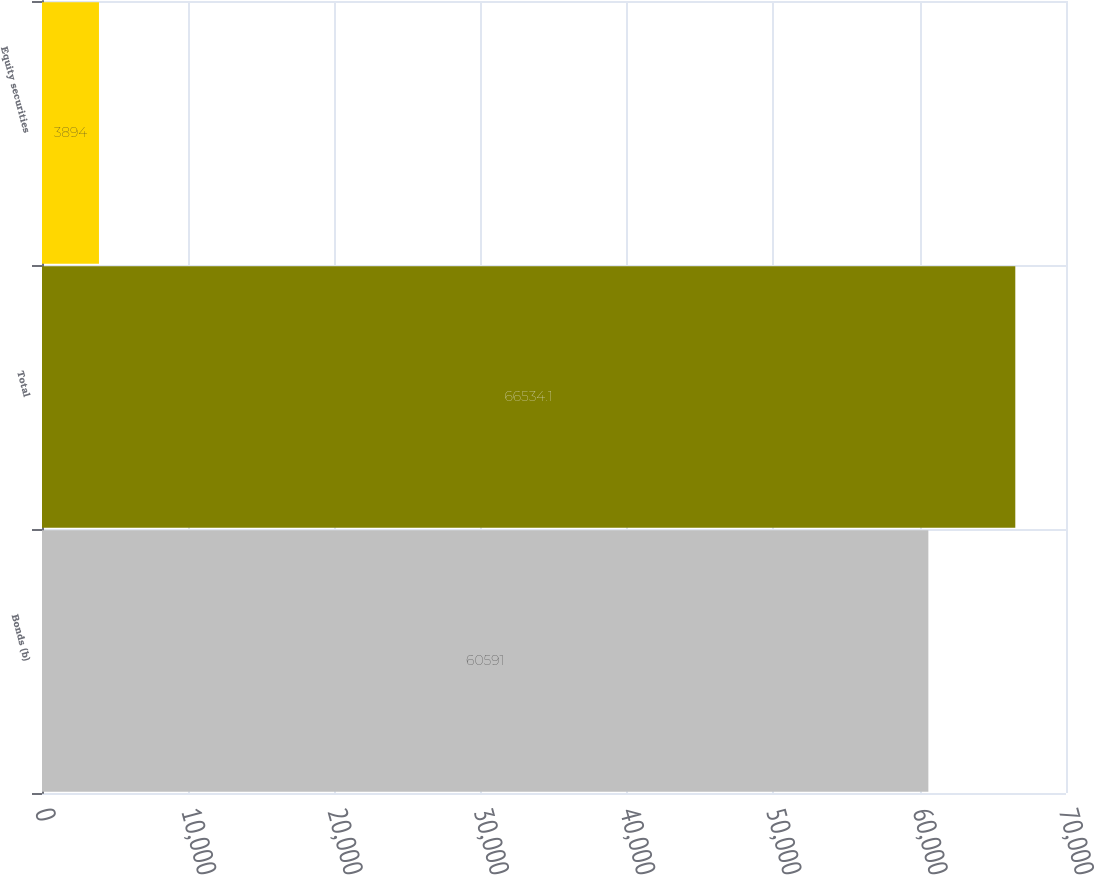<chart> <loc_0><loc_0><loc_500><loc_500><bar_chart><fcel>Bonds (b)<fcel>Total<fcel>Equity securities<nl><fcel>60591<fcel>66534.1<fcel>3894<nl></chart> 